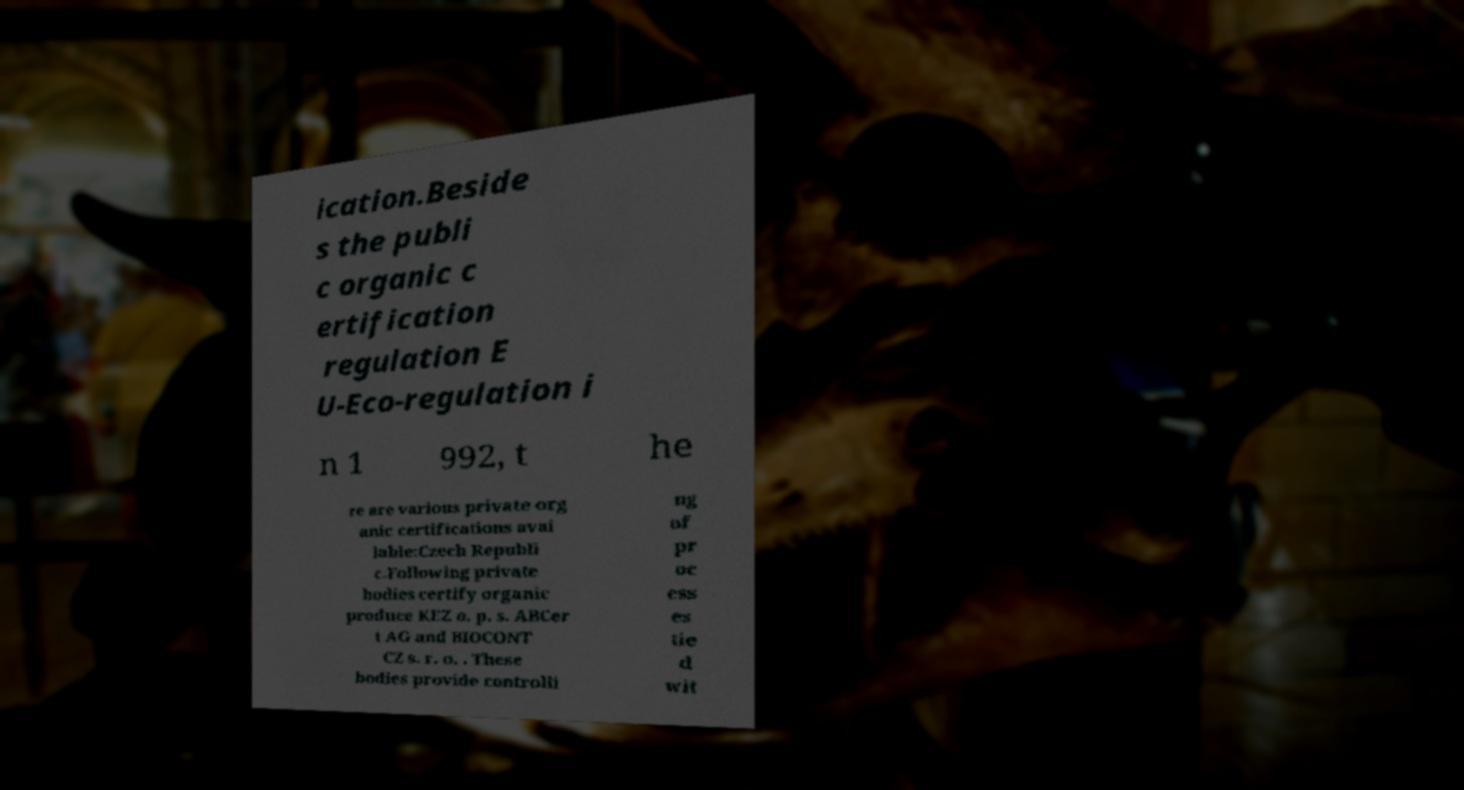Please identify and transcribe the text found in this image. ication.Beside s the publi c organic c ertification regulation E U-Eco-regulation i n 1 992, t he re are various private org anic certifications avai lable:Czech Republi c.Following private bodies certify organic produce KEZ o. p. s. ABCer t AG and BIOCONT CZ s. r. o. . These bodies provide controlli ng of pr oc ess es tie d wit 